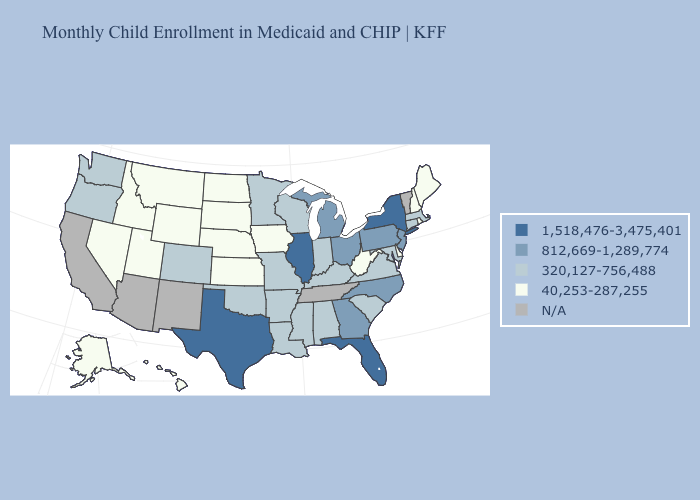Does Colorado have the lowest value in the West?
Keep it brief. No. Name the states that have a value in the range 1,518,476-3,475,401?
Quick response, please. Florida, Illinois, New York, Texas. Among the states that border Arkansas , does Mississippi have the lowest value?
Answer briefly. Yes. Among the states that border Georgia , does Alabama have the highest value?
Keep it brief. No. What is the value of Massachusetts?
Be succinct. 320,127-756,488. Which states have the lowest value in the South?
Keep it brief. Delaware, West Virginia. Which states hav the highest value in the Northeast?
Write a very short answer. New York. Among the states that border Utah , which have the highest value?
Keep it brief. Colorado. Name the states that have a value in the range 812,669-1,289,774?
Keep it brief. Georgia, Michigan, New Jersey, North Carolina, Ohio, Pennsylvania. Name the states that have a value in the range N/A?
Give a very brief answer. Arizona, California, New Mexico, Tennessee, Vermont. Which states have the lowest value in the Northeast?
Give a very brief answer. Maine, New Hampshire, Rhode Island. Name the states that have a value in the range 40,253-287,255?
Short answer required. Alaska, Delaware, Hawaii, Idaho, Iowa, Kansas, Maine, Montana, Nebraska, Nevada, New Hampshire, North Dakota, Rhode Island, South Dakota, Utah, West Virginia, Wyoming. Name the states that have a value in the range N/A?
Be succinct. Arizona, California, New Mexico, Tennessee, Vermont. Among the states that border Iowa , does Illinois have the lowest value?
Concise answer only. No. 